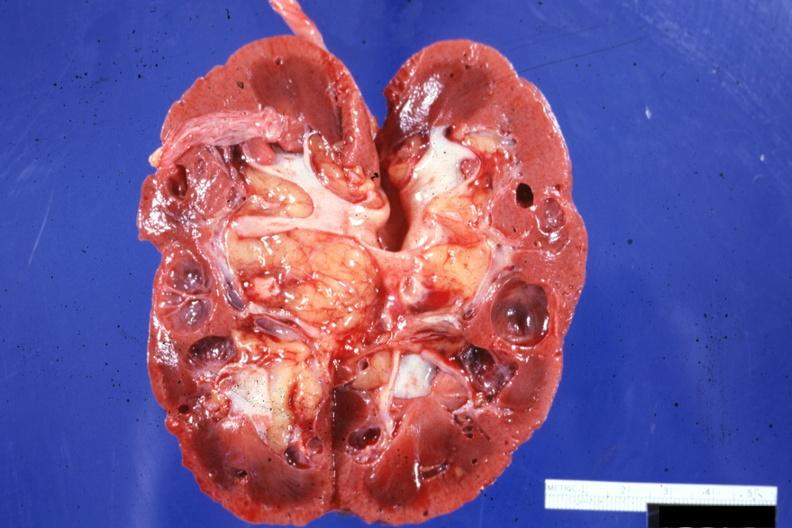s multiple and typical lesions present?
Answer the question using a single word or phrase. No 